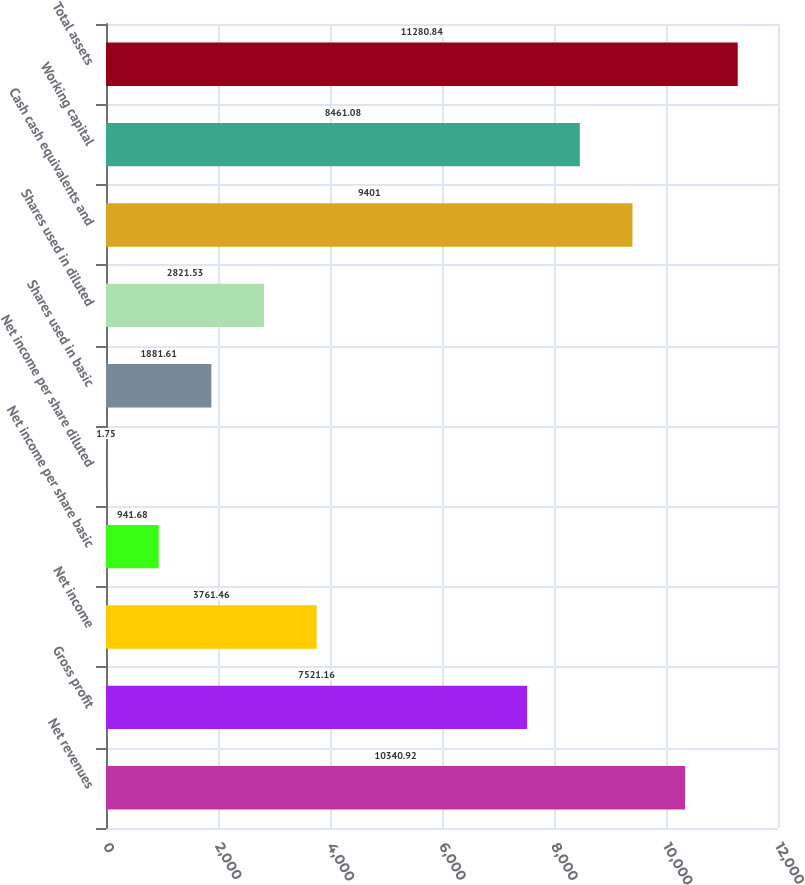Convert chart. <chart><loc_0><loc_0><loc_500><loc_500><bar_chart><fcel>Net revenues<fcel>Gross profit<fcel>Net income<fcel>Net income per share basic<fcel>Net income per share diluted<fcel>Shares used in basic<fcel>Shares used in diluted<fcel>Cash cash equivalents and<fcel>Working capital<fcel>Total assets<nl><fcel>10340.9<fcel>7521.16<fcel>3761.46<fcel>941.68<fcel>1.75<fcel>1881.61<fcel>2821.53<fcel>9401<fcel>8461.08<fcel>11280.8<nl></chart> 